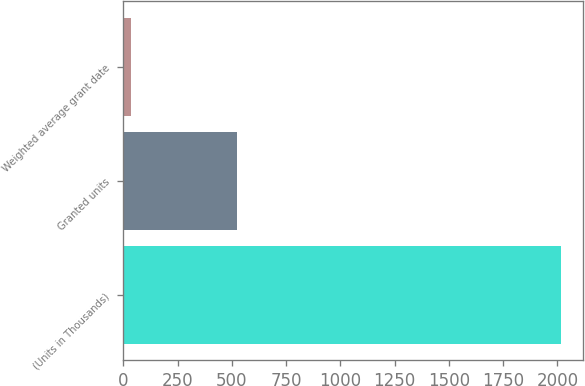Convert chart. <chart><loc_0><loc_0><loc_500><loc_500><bar_chart><fcel>(Units in Thousands)<fcel>Granted units<fcel>Weighted average grant date<nl><fcel>2016<fcel>522<fcel>36<nl></chart> 